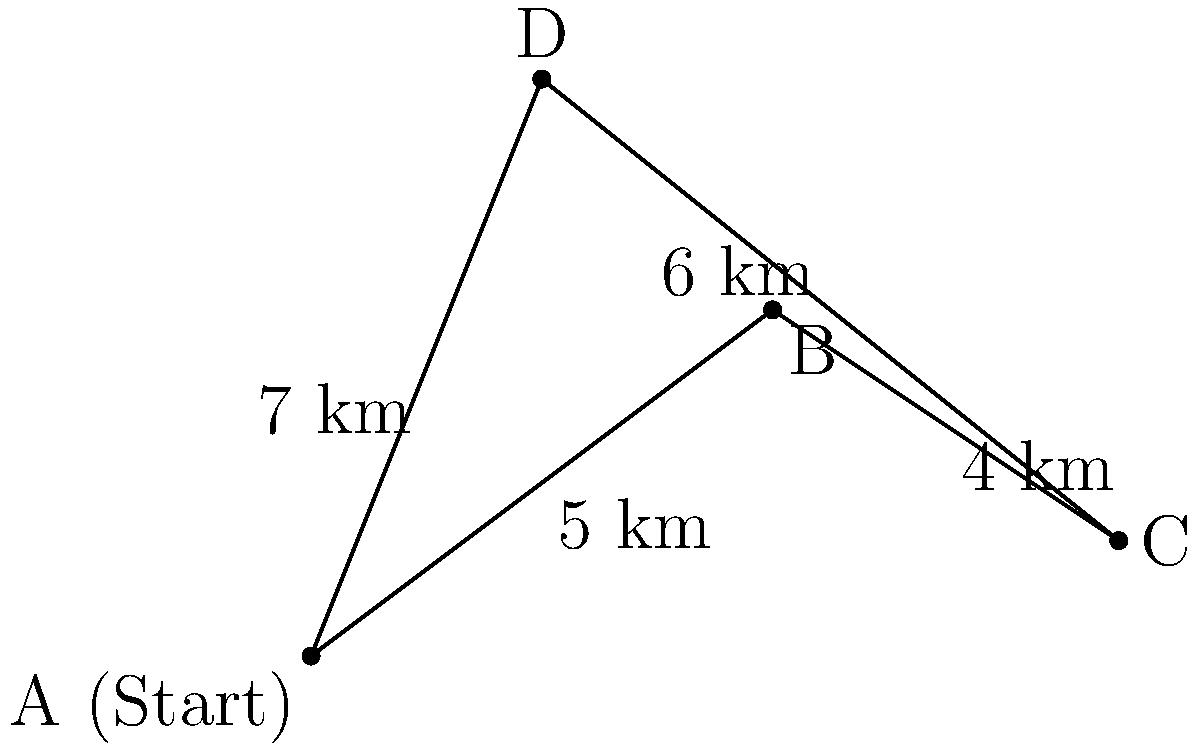As a coordinator for a mobile digital literacy workshop in Lipetsk, you need to plan the most efficient route to cover four locations: A (starting point), B, C, and D. The distances between locations are shown in the diagram. What is the total distance traveled if you follow the optimal route that visits each location once and returns to the starting point? To solve this problem, we need to find the shortest Hamiltonian cycle, which is known as the Traveling Salesman Problem. For a small number of locations, we can solve this by considering all possible routes:

1. There are 3! = 6 possible routes (excluding rotations and reverse order):
   ABCDA, ABDCA, ACBDA, ACDBA, ADBCA, ADCBA

2. Calculate the total distance for each route:
   ABCDA: 5 + 4 + 6 + 7 = 22 km
   ABDCA: 5 + 7 + 6 + 4 = 22 km
   ACBDA: 7 + 4 + 5 + 7 = 23 km
   ACDBA: 7 + 6 + 5 + 7 = 25 km
   ADBCA: 7 + 7 + 4 + 5 = 23 km
   ADCBA: 7 + 6 + 4 + 5 = 22 km

3. The shortest routes are ABCDA, ABDCA, and ADCBA, all with a total distance of 22 km.

Therefore, the optimal route has a total distance of 22 km.
Answer: 22 km 